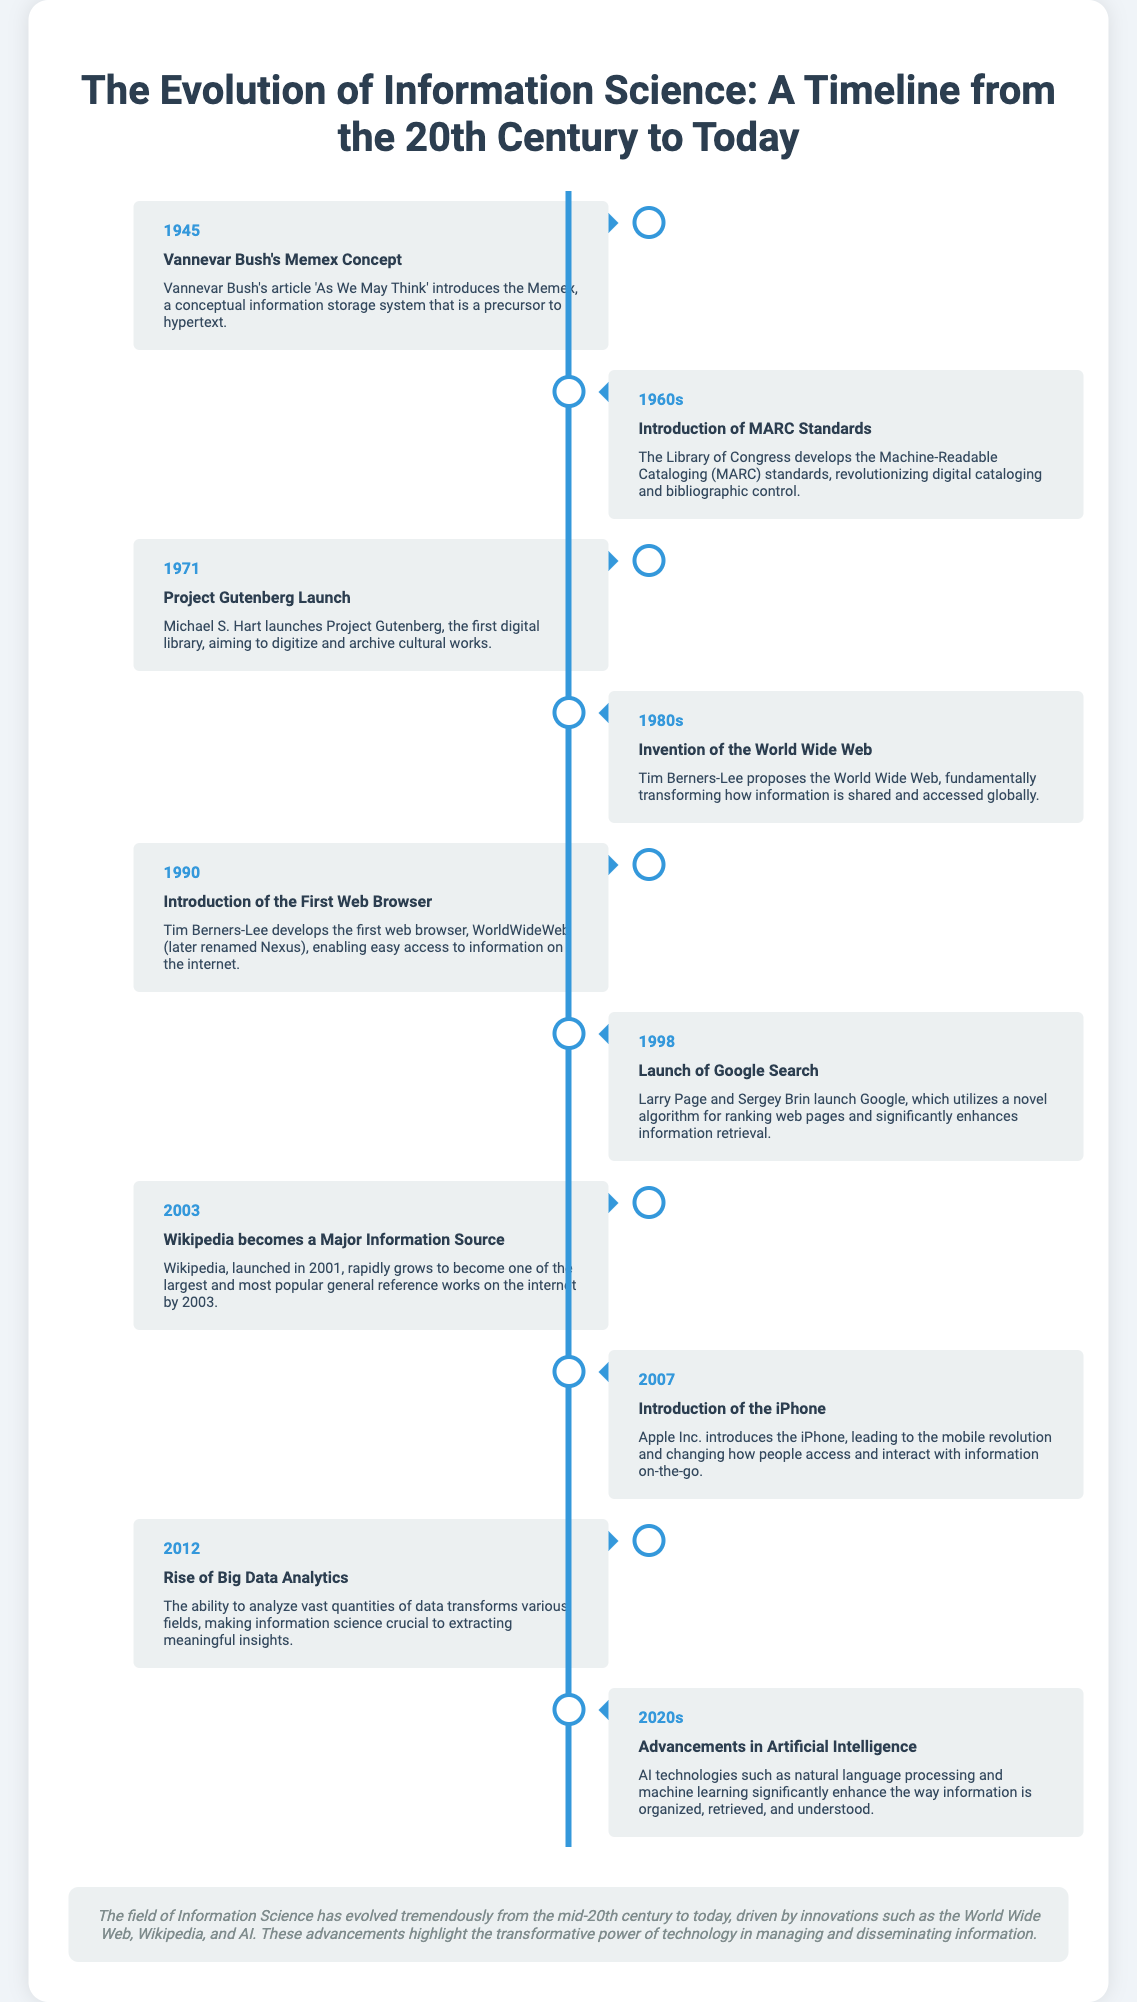What year was the Memex concept introduced? The Memex concept was introduced in Vannevar Bush's article in 1945.
Answer: 1945 Who developed the MARC standards? The MARC standards were developed by the Library of Congress.
Answer: Library of Congress What major event in Information Science occurred in 1998? In 1998, the launch of Google Search significantly enhanced information retrieval.
Answer: Launch of Google Search What device introduced in 2007 changed how people access information? The introduction of the iPhone in 2007 revolutionized mobile access to information.
Answer: iPhone Which project launched in 1971 aimed to digitize cultural works? Project Gutenberg was launched in 1971 to digitize and archive cultural works.
Answer: Project Gutenberg What was a significant outcome of advancements in the 2020s? Advancements in the 2020s led to improvements in how information is organized and understood.
Answer: AI technologies In what decade did Tim Berners-Lee propose the World Wide Web? Tim Berners-Lee proposed the World Wide Web in the 1980s.
Answer: 1980s How did Wikipedia's status change by 2003? By 2003, Wikipedia had grown to become one of the largest general reference works on the internet.
Answer: Major Information Source What is the overarching theme of the document? The document illustrates the evolution and transformative power of technology in Information Science over decades.
Answer: Technology's transformative power 